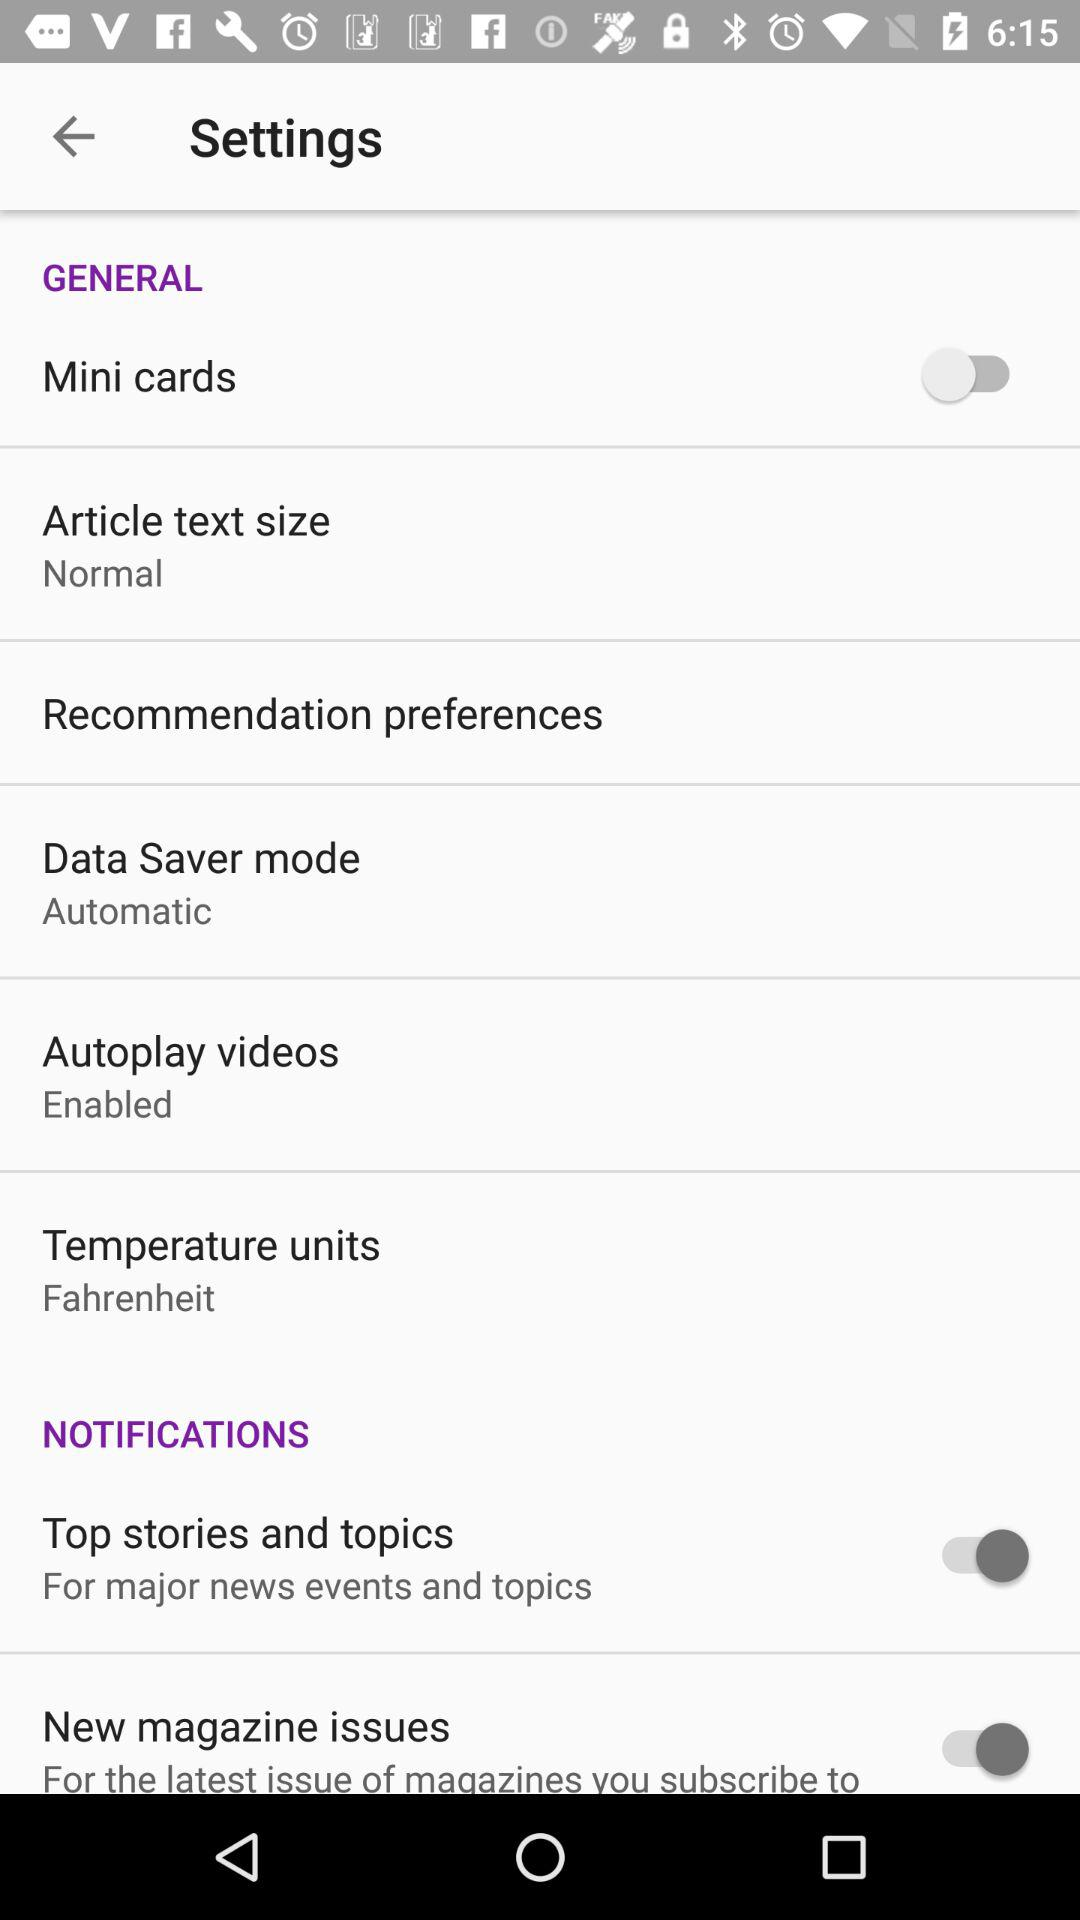What is the setting for "Data Saver mode"? The setting for "Data Saver mode" is "Automatic". 